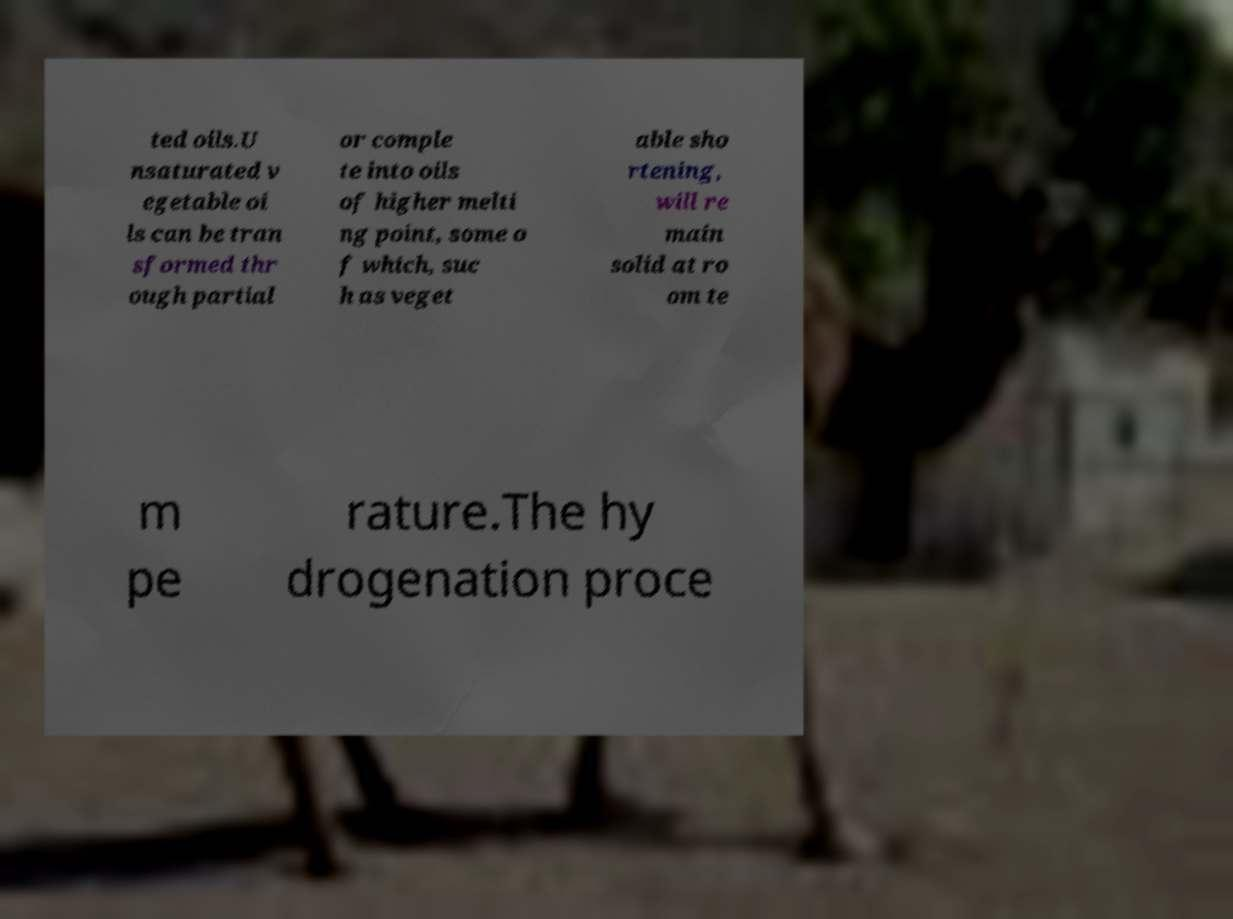I need the written content from this picture converted into text. Can you do that? ted oils.U nsaturated v egetable oi ls can be tran sformed thr ough partial or comple te into oils of higher melti ng point, some o f which, suc h as veget able sho rtening, will re main solid at ro om te m pe rature.The hy drogenation proce 